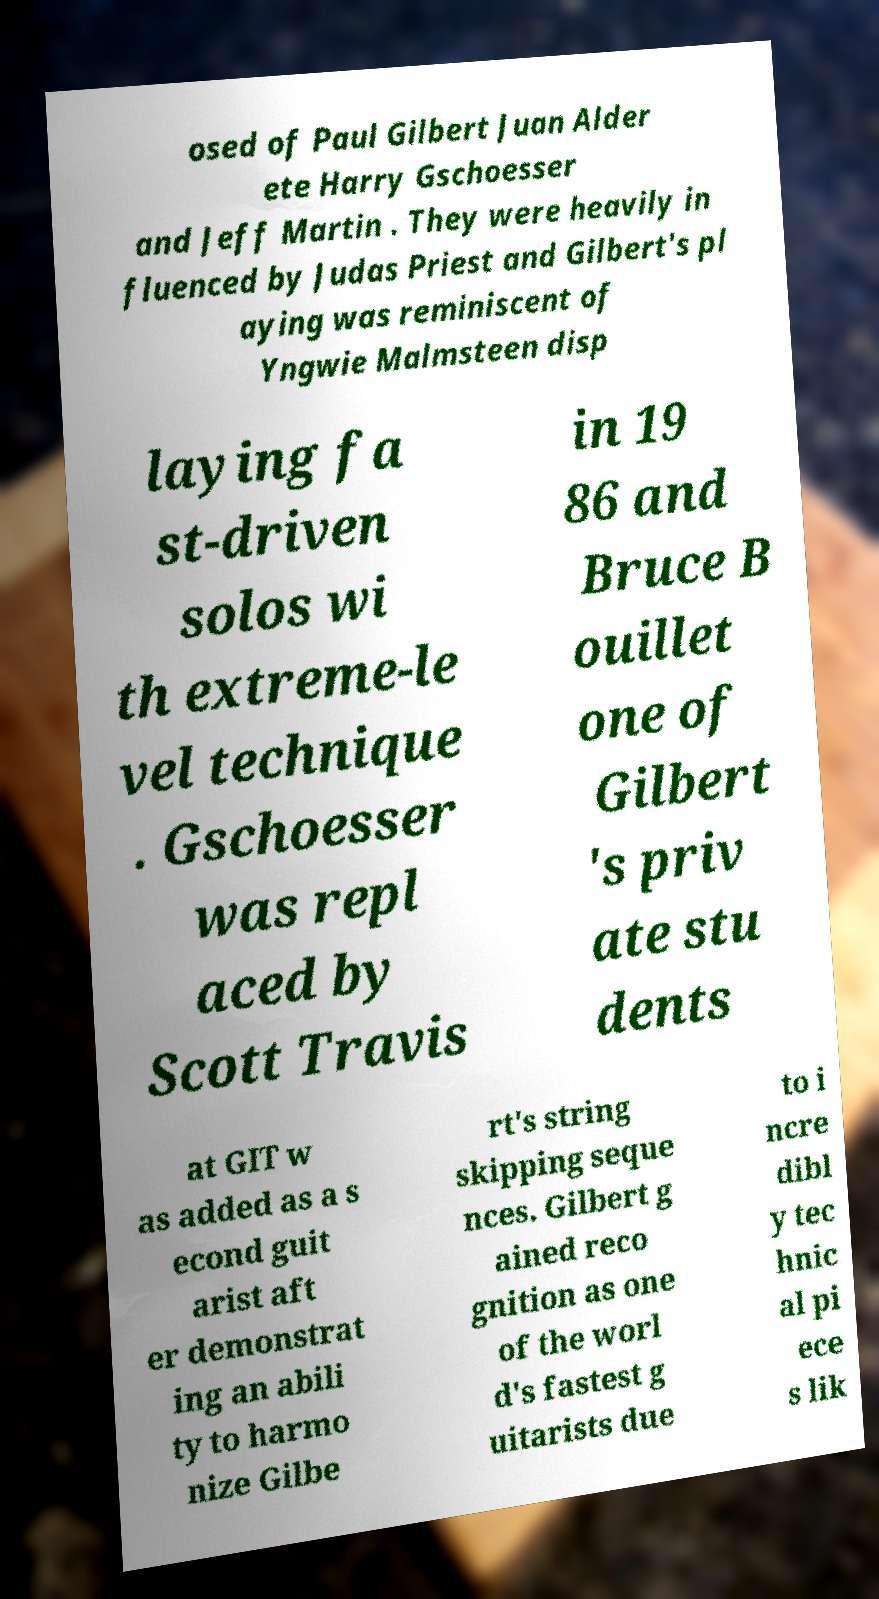Can you read and provide the text displayed in the image?This photo seems to have some interesting text. Can you extract and type it out for me? osed of Paul Gilbert Juan Alder ete Harry Gschoesser and Jeff Martin . They were heavily in fluenced by Judas Priest and Gilbert's pl aying was reminiscent of Yngwie Malmsteen disp laying fa st-driven solos wi th extreme-le vel technique . Gschoesser was repl aced by Scott Travis in 19 86 and Bruce B ouillet one of Gilbert 's priv ate stu dents at GIT w as added as a s econd guit arist aft er demonstrat ing an abili ty to harmo nize Gilbe rt's string skipping seque nces. Gilbert g ained reco gnition as one of the worl d's fastest g uitarists due to i ncre dibl y tec hnic al pi ece s lik 